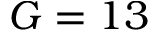<formula> <loc_0><loc_0><loc_500><loc_500>G = 1 3</formula> 